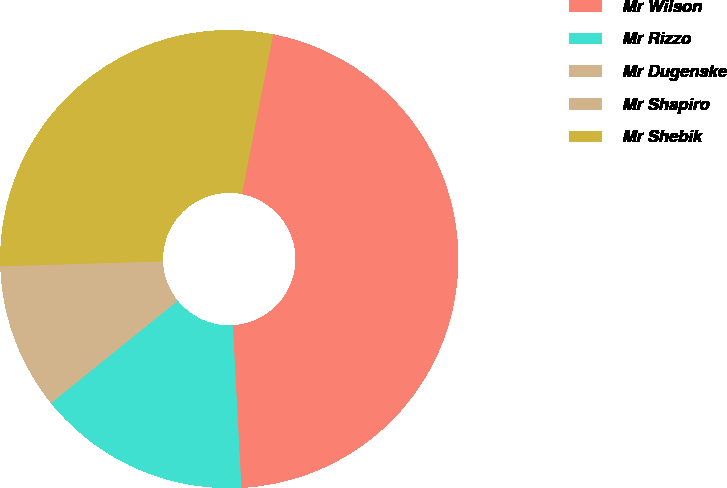<chart> <loc_0><loc_0><loc_500><loc_500><pie_chart><fcel>Mr Wilson<fcel>Mr Rizzo<fcel>Mr Dugenske<fcel>Mr Shapiro<fcel>Mr Shebik<nl><fcel>46.1%<fcel>15.03%<fcel>7.31%<fcel>3.0%<fcel>28.57%<nl></chart> 